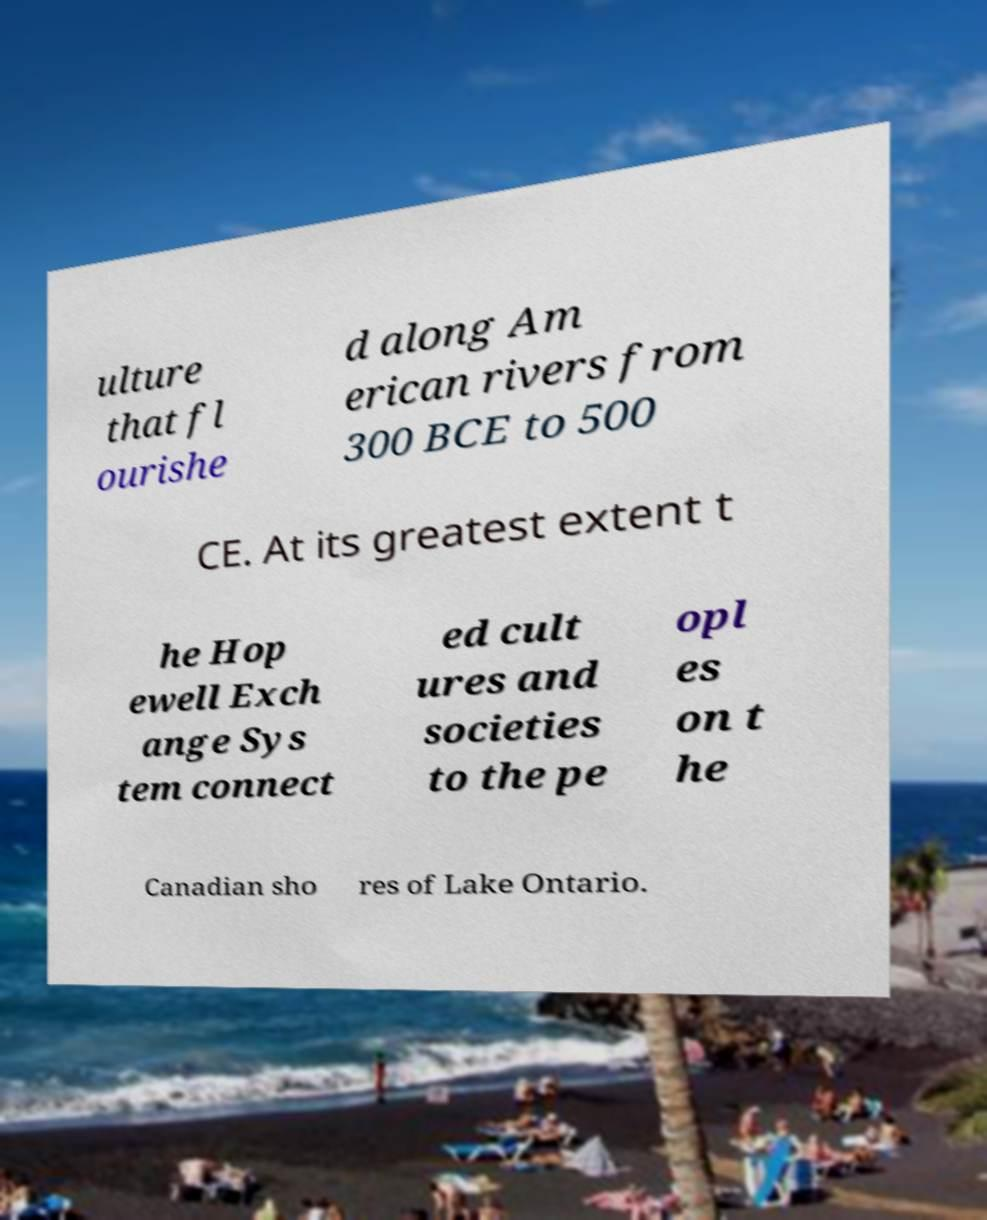Could you assist in decoding the text presented in this image and type it out clearly? ulture that fl ourishe d along Am erican rivers from 300 BCE to 500 CE. At its greatest extent t he Hop ewell Exch ange Sys tem connect ed cult ures and societies to the pe opl es on t he Canadian sho res of Lake Ontario. 